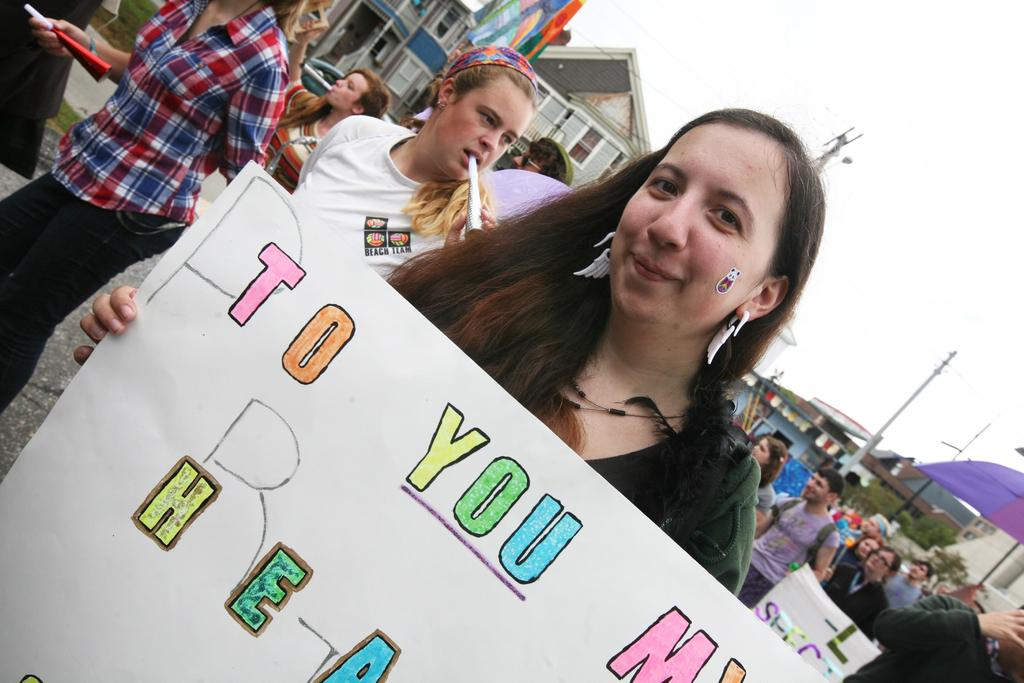What is the woman in the image holding? The woman is holding a placard in the image. What can be seen happening in the background of the image? People are walking in the background of the image. What type of structures are visible in the background of the image? There are houses in the background of the image. What else can be seen in the background of the image? Electric poles are present in the background of the image. What is visible above the structures and people in the image? The sky is visible in the image. What type of yam is being served at the hour depicted in the image? There is no yam or indication of time in the image; it features a woman holding a placard and people walking in the background. 